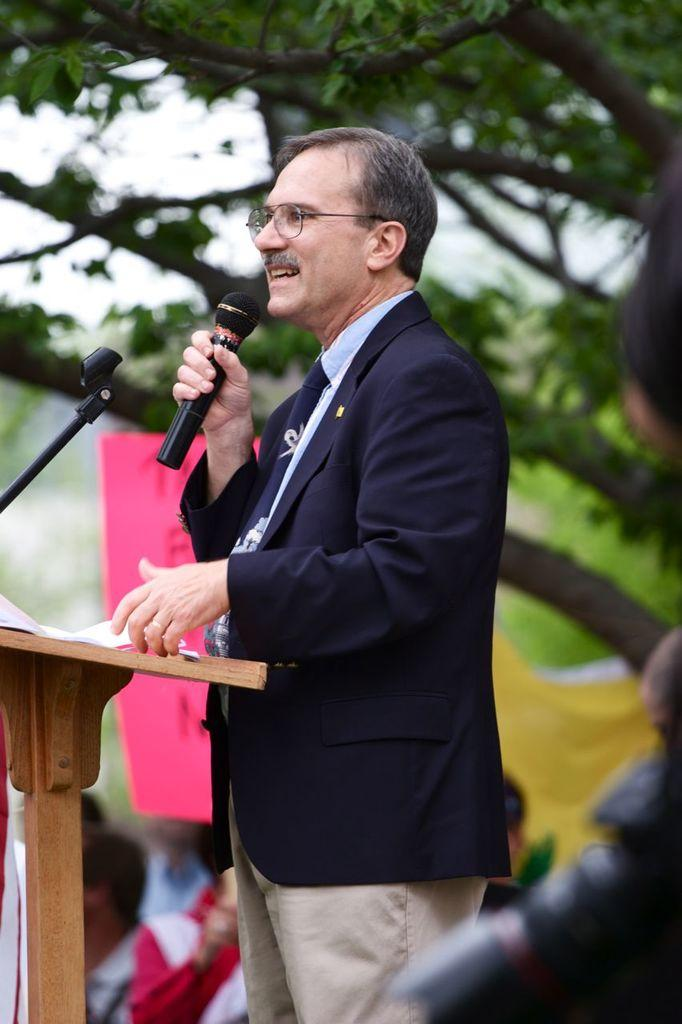Who is the main subject in the image? There is a man in the image. What is the man doing in the image? The man is standing and holding a mic in his hand. Can you describe the background of the image? The background of the image is blurry. Where is the shelf located in the image? There is no shelf present in the image. How does the man plan to join the other people in the image? The image does not show any other people, so it is not possible to determine how the man plans to join them. 